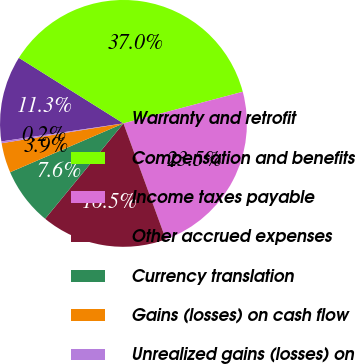Convert chart. <chart><loc_0><loc_0><loc_500><loc_500><pie_chart><fcel>Warranty and retrofit<fcel>Compensation and benefits<fcel>Income taxes payable<fcel>Other accrued expenses<fcel>Currency translation<fcel>Gains (losses) on cash flow<fcel>Unrealized gains (losses) on<nl><fcel>11.25%<fcel>36.96%<fcel>23.54%<fcel>16.52%<fcel>7.58%<fcel>3.91%<fcel>0.23%<nl></chart> 